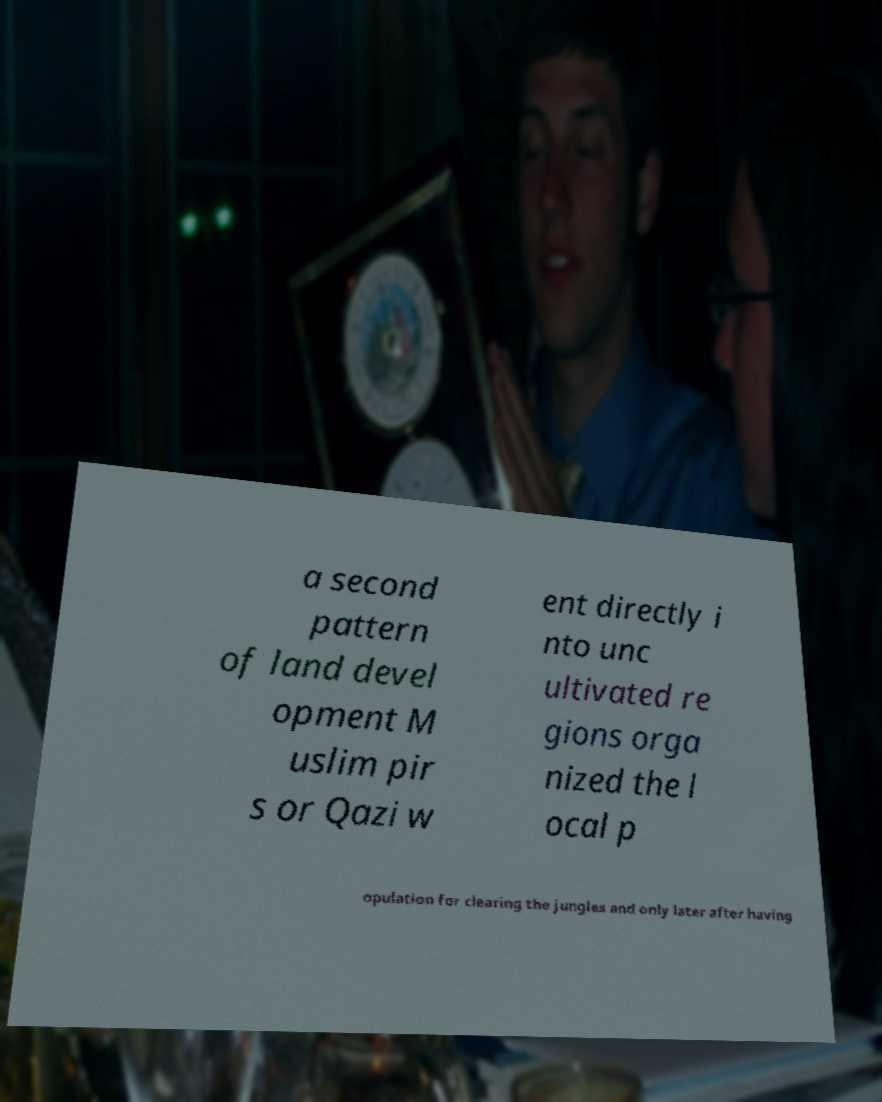Could you extract and type out the text from this image? a second pattern of land devel opment M uslim pir s or Qazi w ent directly i nto unc ultivated re gions orga nized the l ocal p opulation for clearing the jungles and only later after having 